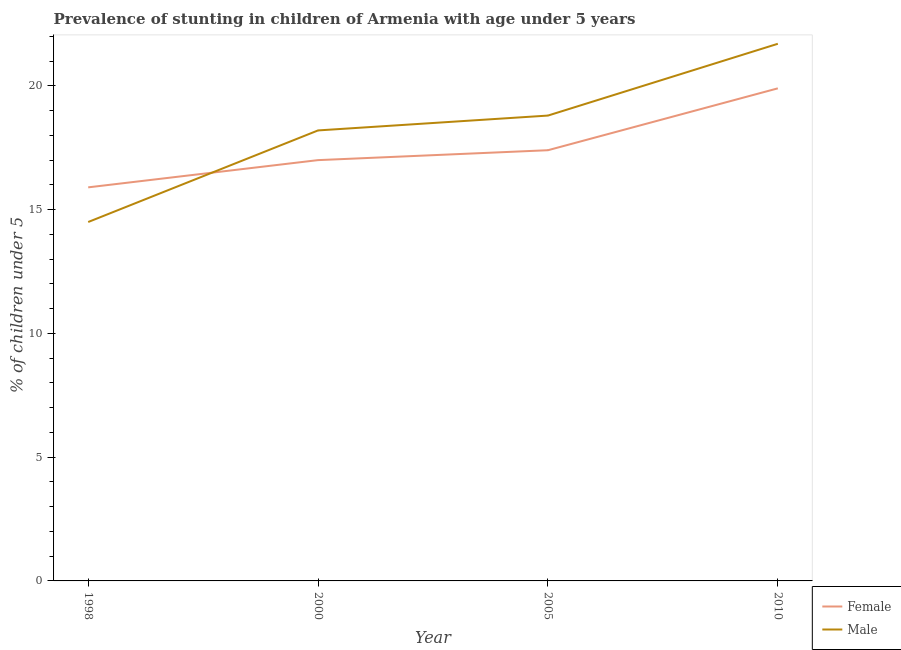Is the number of lines equal to the number of legend labels?
Offer a terse response. Yes. Across all years, what is the maximum percentage of stunted male children?
Offer a very short reply. 21.7. Across all years, what is the minimum percentage of stunted male children?
Your answer should be very brief. 14.5. In which year was the percentage of stunted male children maximum?
Your answer should be very brief. 2010. In which year was the percentage of stunted male children minimum?
Ensure brevity in your answer.  1998. What is the total percentage of stunted male children in the graph?
Your response must be concise. 73.2. What is the difference between the percentage of stunted female children in 2000 and that in 2010?
Your answer should be very brief. -2.9. What is the difference between the percentage of stunted male children in 2010 and the percentage of stunted female children in 2000?
Your response must be concise. 4.7. What is the average percentage of stunted male children per year?
Your answer should be compact. 18.3. In the year 1998, what is the difference between the percentage of stunted male children and percentage of stunted female children?
Your answer should be compact. -1.4. In how many years, is the percentage of stunted female children greater than 3 %?
Your response must be concise. 4. What is the ratio of the percentage of stunted female children in 1998 to that in 2005?
Provide a succinct answer. 0.91. Is the difference between the percentage of stunted male children in 2000 and 2010 greater than the difference between the percentage of stunted female children in 2000 and 2010?
Offer a terse response. No. What is the difference between the highest and the lowest percentage of stunted male children?
Offer a very short reply. 7.2. In how many years, is the percentage of stunted male children greater than the average percentage of stunted male children taken over all years?
Provide a succinct answer. 2. Is the percentage of stunted male children strictly less than the percentage of stunted female children over the years?
Keep it short and to the point. No. What is the difference between two consecutive major ticks on the Y-axis?
Provide a succinct answer. 5. Does the graph contain any zero values?
Your response must be concise. No. Does the graph contain grids?
Provide a succinct answer. No. Where does the legend appear in the graph?
Offer a terse response. Bottom right. How many legend labels are there?
Provide a succinct answer. 2. What is the title of the graph?
Your answer should be very brief. Prevalence of stunting in children of Armenia with age under 5 years. What is the label or title of the Y-axis?
Provide a short and direct response.  % of children under 5. What is the  % of children under 5 in Female in 1998?
Ensure brevity in your answer.  15.9. What is the  % of children under 5 in Male in 2000?
Your answer should be compact. 18.2. What is the  % of children under 5 in Female in 2005?
Keep it short and to the point. 17.4. What is the  % of children under 5 in Male in 2005?
Keep it short and to the point. 18.8. What is the  % of children under 5 in Female in 2010?
Your response must be concise. 19.9. What is the  % of children under 5 in Male in 2010?
Your answer should be compact. 21.7. Across all years, what is the maximum  % of children under 5 of Female?
Offer a terse response. 19.9. Across all years, what is the maximum  % of children under 5 of Male?
Offer a very short reply. 21.7. Across all years, what is the minimum  % of children under 5 in Female?
Your answer should be compact. 15.9. What is the total  % of children under 5 of Female in the graph?
Your answer should be compact. 70.2. What is the total  % of children under 5 in Male in the graph?
Ensure brevity in your answer.  73.2. What is the difference between the  % of children under 5 of Male in 1998 and that in 2000?
Keep it short and to the point. -3.7. What is the difference between the  % of children under 5 in Male in 1998 and that in 2005?
Ensure brevity in your answer.  -4.3. What is the difference between the  % of children under 5 in Female in 1998 and that in 2010?
Give a very brief answer. -4. What is the difference between the  % of children under 5 of Male in 1998 and that in 2010?
Offer a very short reply. -7.2. What is the difference between the  % of children under 5 in Female in 2000 and that in 2005?
Your answer should be very brief. -0.4. What is the difference between the  % of children under 5 in Male in 2000 and that in 2005?
Offer a very short reply. -0.6. What is the difference between the  % of children under 5 of Female in 2000 and that in 2010?
Provide a succinct answer. -2.9. What is the difference between the  % of children under 5 in Male in 2000 and that in 2010?
Ensure brevity in your answer.  -3.5. What is the difference between the  % of children under 5 in Male in 2005 and that in 2010?
Offer a terse response. -2.9. What is the difference between the  % of children under 5 in Female in 1998 and the  % of children under 5 in Male in 2005?
Keep it short and to the point. -2.9. What is the difference between the  % of children under 5 of Female in 1998 and the  % of children under 5 of Male in 2010?
Offer a very short reply. -5.8. What is the difference between the  % of children under 5 in Female in 2000 and the  % of children under 5 in Male in 2010?
Make the answer very short. -4.7. What is the difference between the  % of children under 5 in Female in 2005 and the  % of children under 5 in Male in 2010?
Ensure brevity in your answer.  -4.3. What is the average  % of children under 5 in Female per year?
Your response must be concise. 17.55. What is the average  % of children under 5 of Male per year?
Your response must be concise. 18.3. In the year 1998, what is the difference between the  % of children under 5 of Female and  % of children under 5 of Male?
Your answer should be compact. 1.4. What is the ratio of the  % of children under 5 of Female in 1998 to that in 2000?
Make the answer very short. 0.94. What is the ratio of the  % of children under 5 in Male in 1998 to that in 2000?
Make the answer very short. 0.8. What is the ratio of the  % of children under 5 of Female in 1998 to that in 2005?
Your answer should be compact. 0.91. What is the ratio of the  % of children under 5 in Male in 1998 to that in 2005?
Your answer should be very brief. 0.77. What is the ratio of the  % of children under 5 in Female in 1998 to that in 2010?
Make the answer very short. 0.8. What is the ratio of the  % of children under 5 in Male in 1998 to that in 2010?
Ensure brevity in your answer.  0.67. What is the ratio of the  % of children under 5 in Female in 2000 to that in 2005?
Offer a terse response. 0.98. What is the ratio of the  % of children under 5 of Male in 2000 to that in 2005?
Your answer should be compact. 0.97. What is the ratio of the  % of children under 5 in Female in 2000 to that in 2010?
Provide a succinct answer. 0.85. What is the ratio of the  % of children under 5 in Male in 2000 to that in 2010?
Ensure brevity in your answer.  0.84. What is the ratio of the  % of children under 5 in Female in 2005 to that in 2010?
Offer a very short reply. 0.87. What is the ratio of the  % of children under 5 of Male in 2005 to that in 2010?
Provide a short and direct response. 0.87. What is the difference between the highest and the lowest  % of children under 5 in Male?
Your response must be concise. 7.2. 